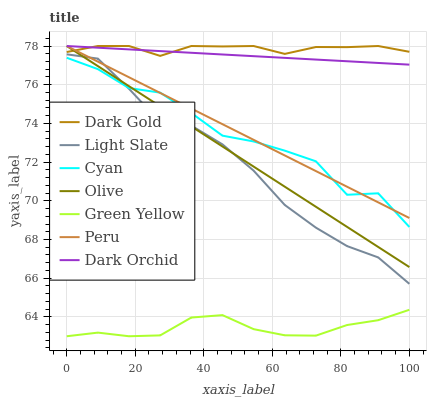Does Green Yellow have the minimum area under the curve?
Answer yes or no. Yes. Does Dark Gold have the maximum area under the curve?
Answer yes or no. Yes. Does Light Slate have the minimum area under the curve?
Answer yes or no. No. Does Light Slate have the maximum area under the curve?
Answer yes or no. No. Is Peru the smoothest?
Answer yes or no. Yes. Is Cyan the roughest?
Answer yes or no. Yes. Is Light Slate the smoothest?
Answer yes or no. No. Is Light Slate the roughest?
Answer yes or no. No. Does Green Yellow have the lowest value?
Answer yes or no. Yes. Does Light Slate have the lowest value?
Answer yes or no. No. Does Olive have the highest value?
Answer yes or no. Yes. Does Light Slate have the highest value?
Answer yes or no. No. Is Cyan less than Dark Gold?
Answer yes or no. Yes. Is Dark Orchid greater than Green Yellow?
Answer yes or no. Yes. Does Dark Orchid intersect Peru?
Answer yes or no. Yes. Is Dark Orchid less than Peru?
Answer yes or no. No. Is Dark Orchid greater than Peru?
Answer yes or no. No. Does Cyan intersect Dark Gold?
Answer yes or no. No. 